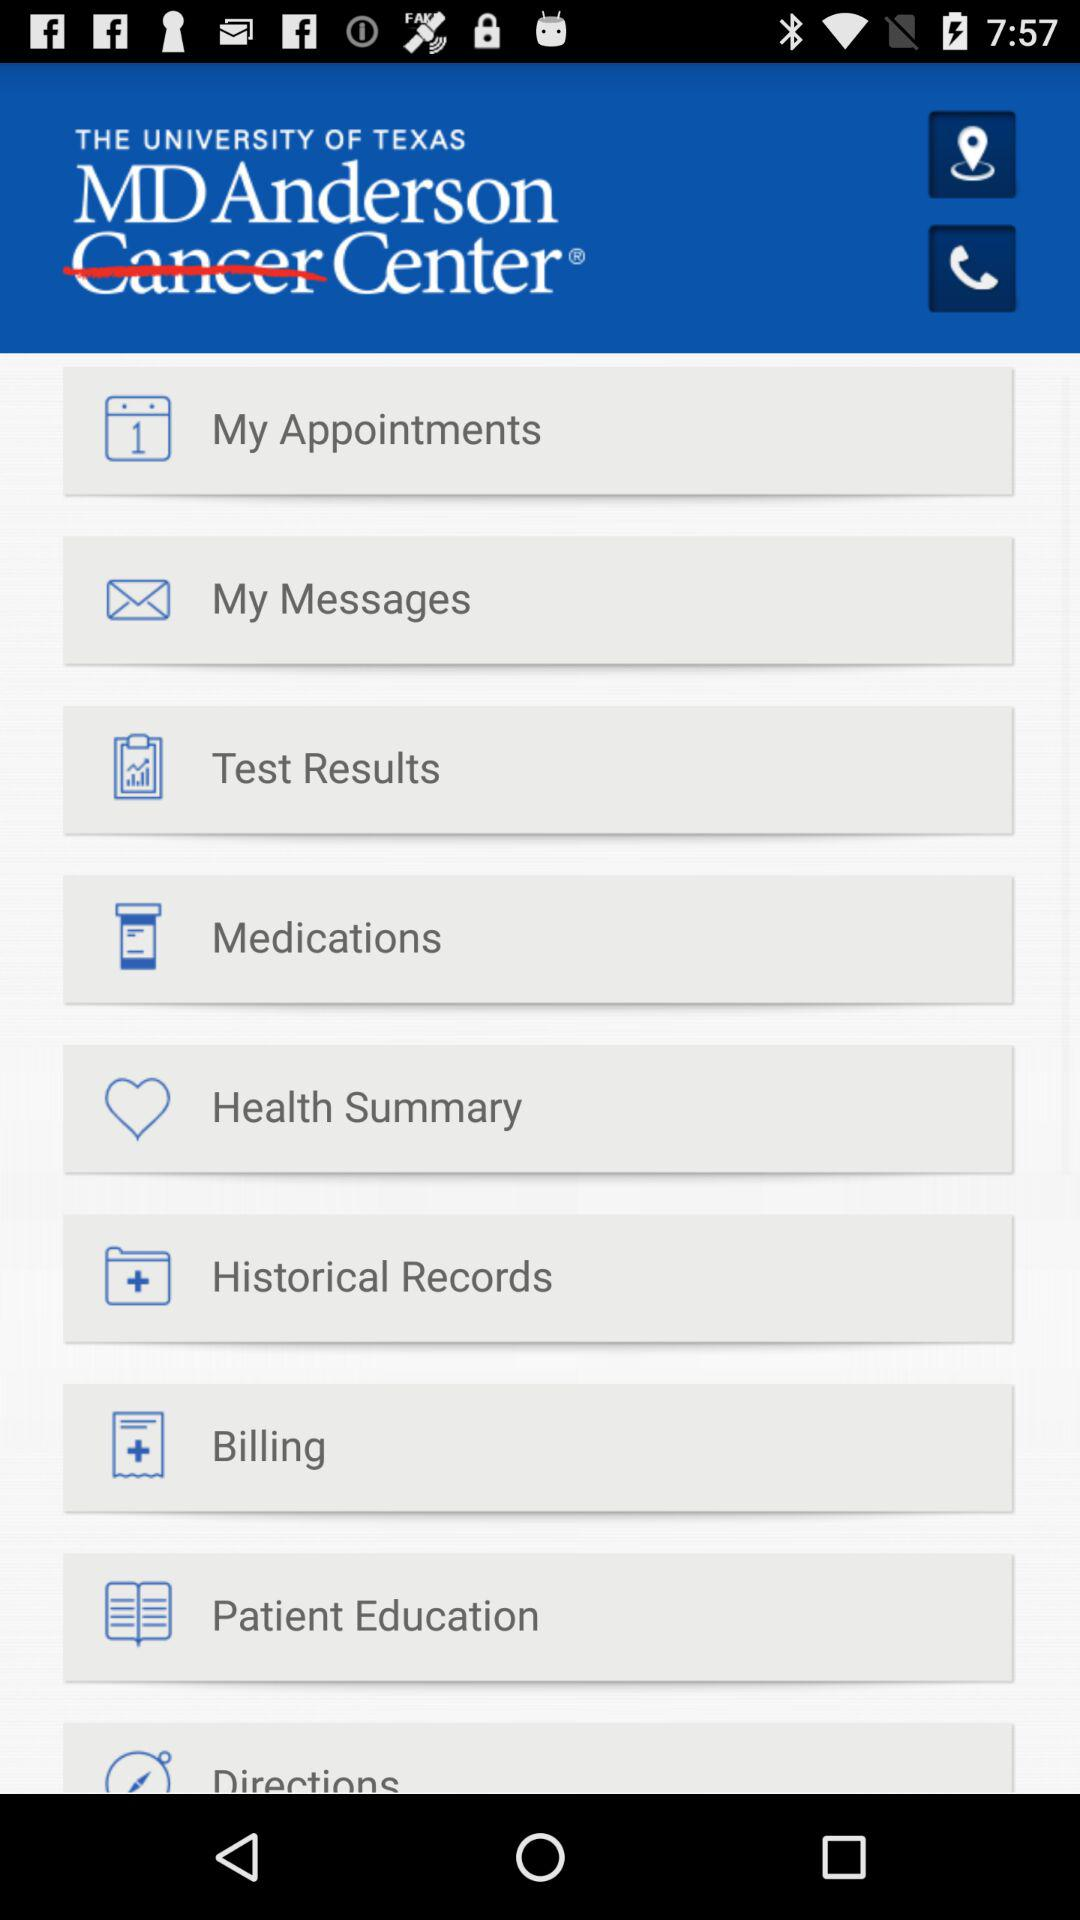What is the name of the application?
When the provided information is insufficient, respond with <no answer>. <no answer> 